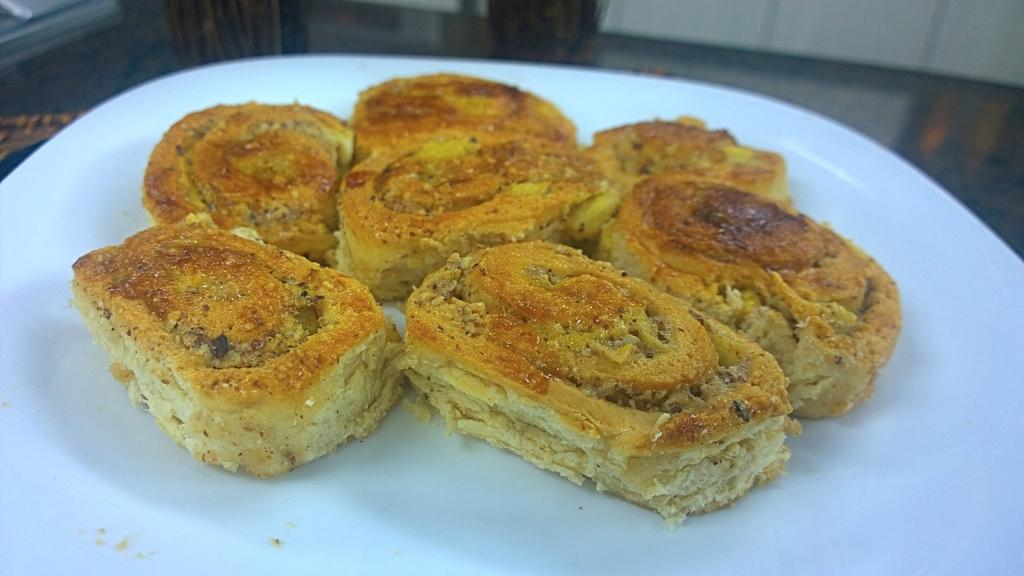What can be seen on the plate in the image? There is a food item on the plate in the image. Can you describe the food item on the plate? Unfortunately, the specific food item cannot be determined from the provided facts. How many apples can be seen on the window in the image? There is no mention of apples or a window in the provided facts, so it cannot be determined from the image. 